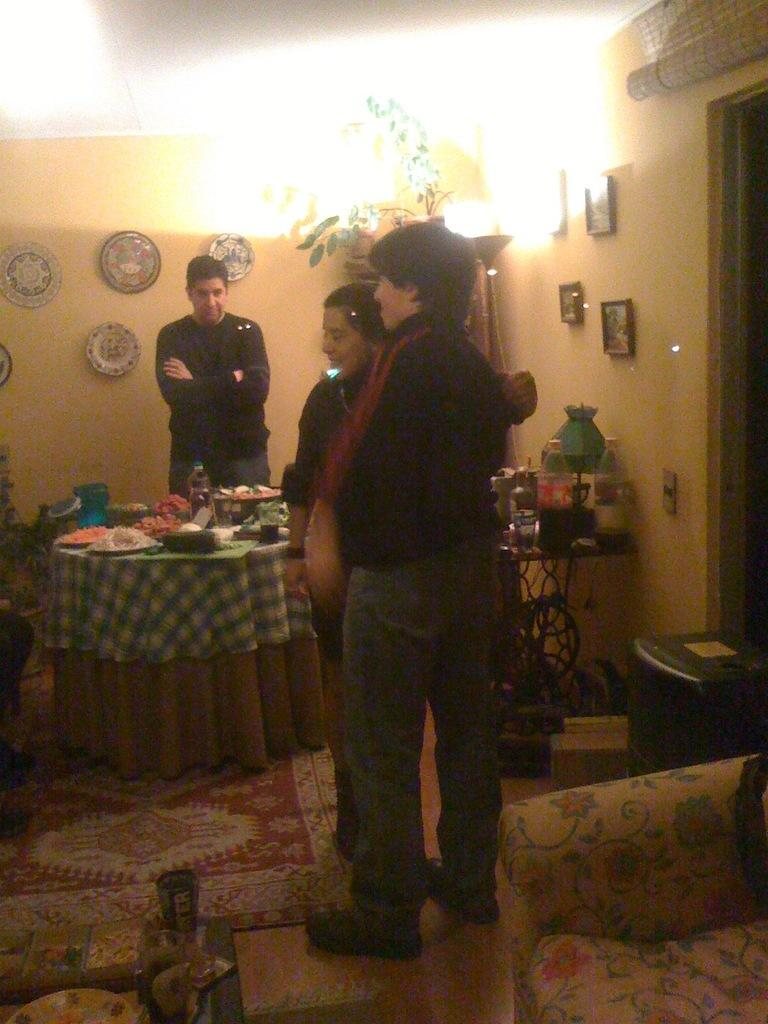How many people are in the image? There are three people standing in the image. What are the people doing in the image? The people are standing. Can you describe any objects or features in the image? There is a light in the image. What type of root can be seen growing from the ground in the image? There is no root visible in the image; it only features three people standing and a light. 